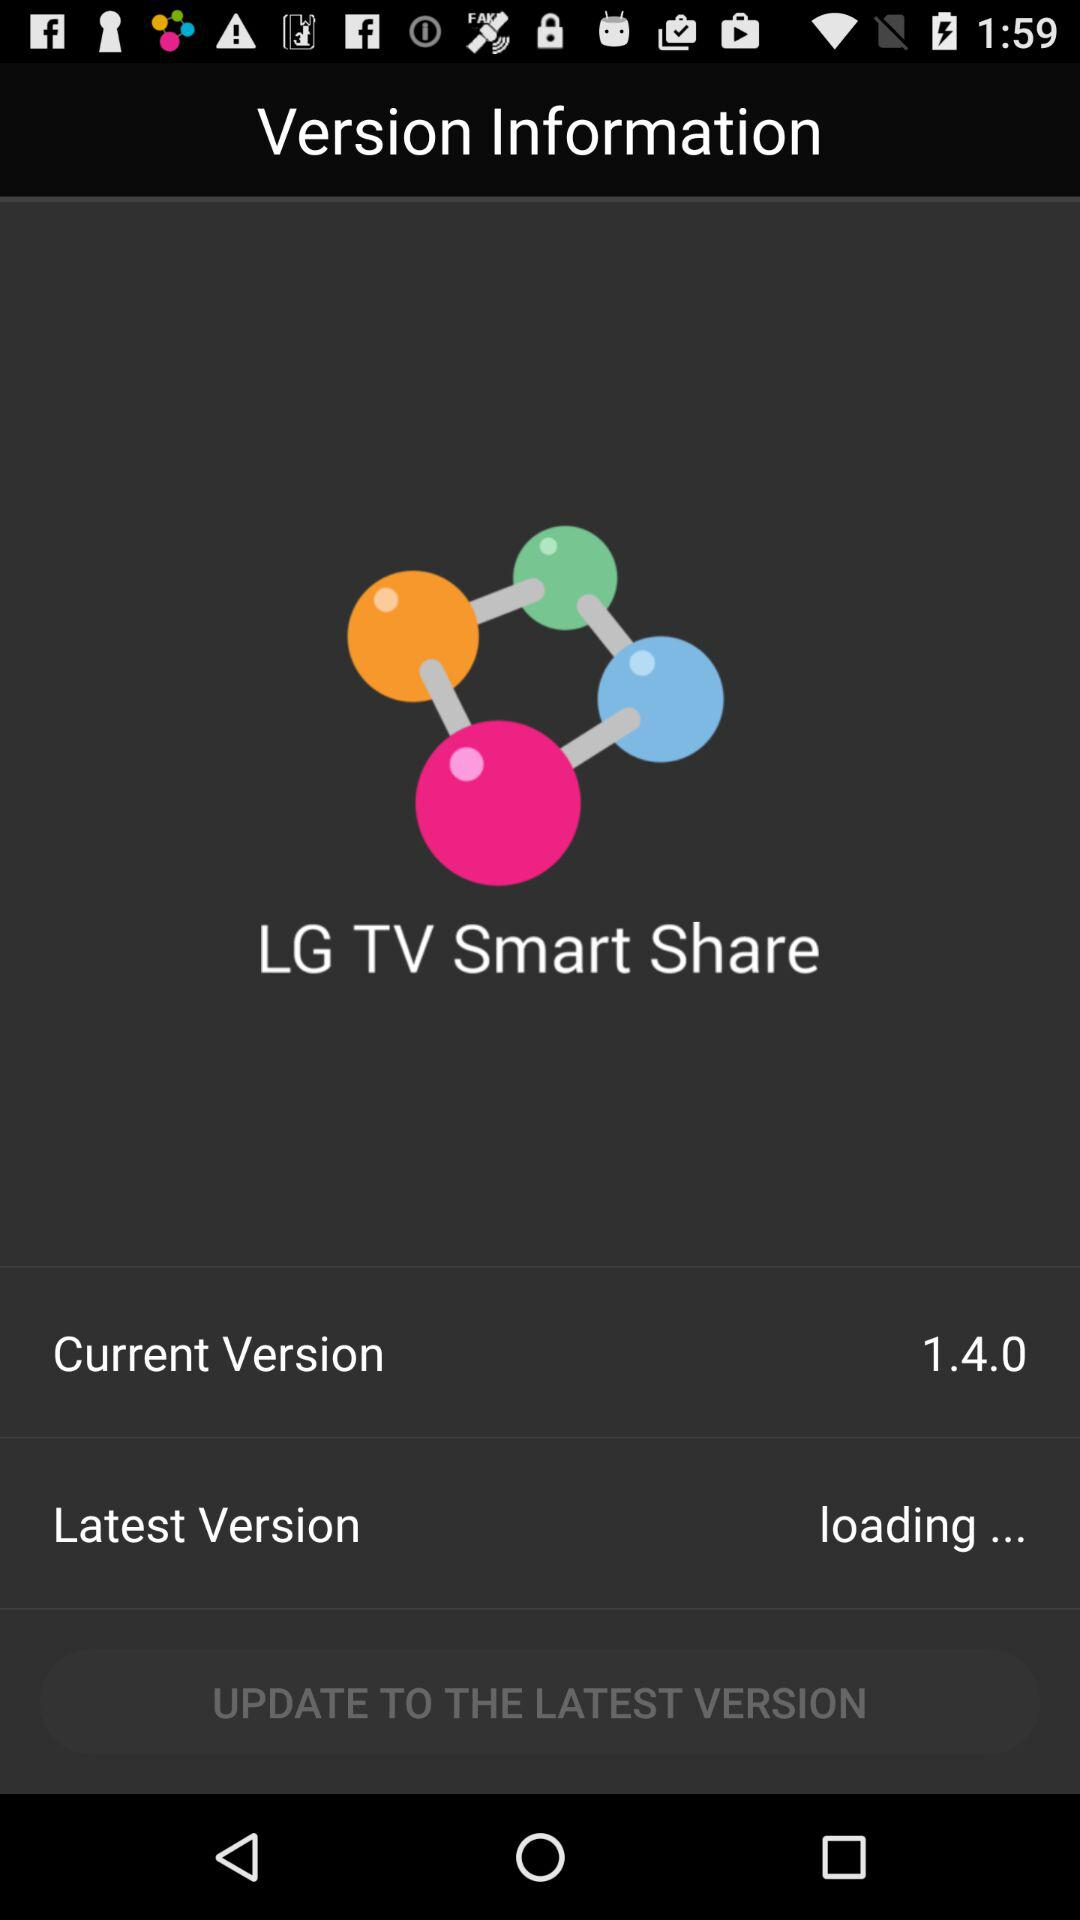What is the name of the application? The name of the application is "LG TV Smart Share". 